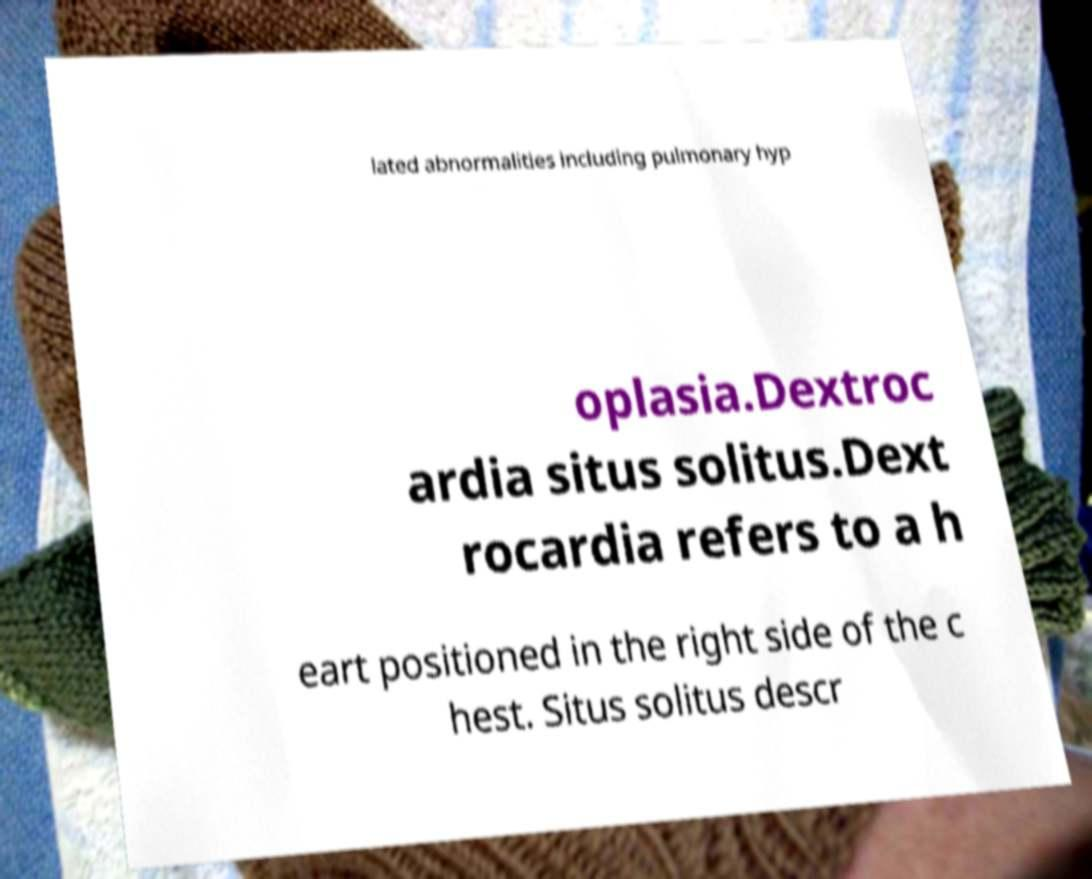For documentation purposes, I need the text within this image transcribed. Could you provide that? lated abnormalities including pulmonary hyp oplasia.Dextroc ardia situs solitus.Dext rocardia refers to a h eart positioned in the right side of the c hest. Situs solitus descr 